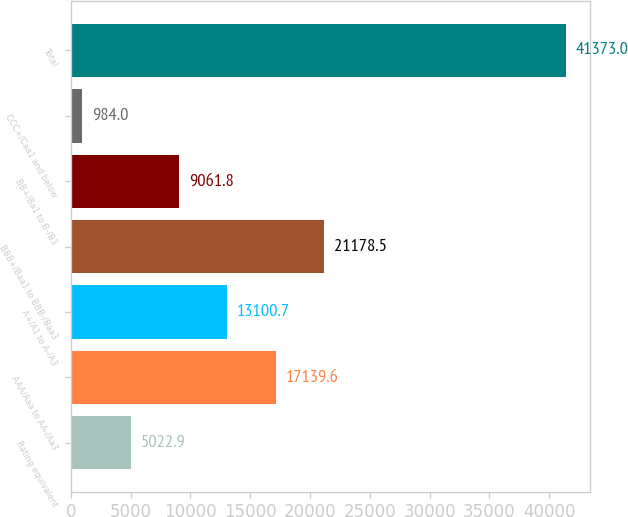Convert chart. <chart><loc_0><loc_0><loc_500><loc_500><bar_chart><fcel>Rating equivalent<fcel>AAA/Aaa to AA-/Aa3<fcel>A+/A1 to A-/A3<fcel>BBB+/Baa1 to BBB-/Baa3<fcel>BB+/Ba1 to B-/B3<fcel>CCC+/Caa1 and below<fcel>Total<nl><fcel>5022.9<fcel>17139.6<fcel>13100.7<fcel>21178.5<fcel>9061.8<fcel>984<fcel>41373<nl></chart> 